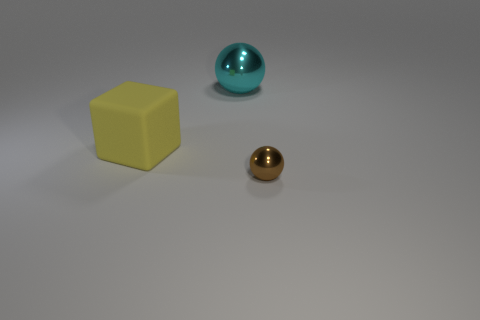Can you describe the colors of the objects in the image? Certainly! In the image, we have three objects, each with its own unique color: a yellow cube, a shiny gold sphere, and a larger turquoise sphere that has a reflective surface. 